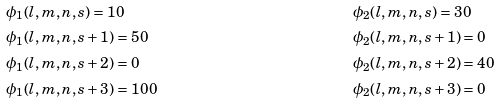Convert formula to latex. <formula><loc_0><loc_0><loc_500><loc_500>& \phi _ { 1 } ( l , m , n , s ) = 1 0 & & \phi _ { 2 } ( l , m , n , s ) = 3 0 \\ & \phi _ { 1 } ( l , m , n , s + 1 ) = 5 0 & & \phi _ { 2 } ( l , m , n , s + 1 ) = 0 \\ & \phi _ { 1 } ( l , m , n , s + 2 ) = 0 & & \phi _ { 2 } ( l , m , n , s + 2 ) = 4 0 \\ & \phi _ { 1 } ( l , m , n , s + 3 ) = 1 0 0 & & \phi _ { 2 } ( l , m , n , s + 3 ) = 0</formula> 